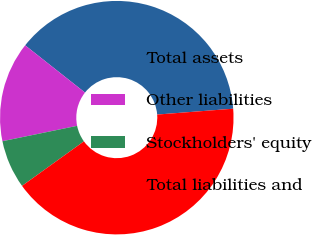<chart> <loc_0><loc_0><loc_500><loc_500><pie_chart><fcel>Total assets<fcel>Other liabilities<fcel>Stockholders' equity<fcel>Total liabilities and<nl><fcel>38.14%<fcel>13.87%<fcel>6.7%<fcel>41.29%<nl></chart> 